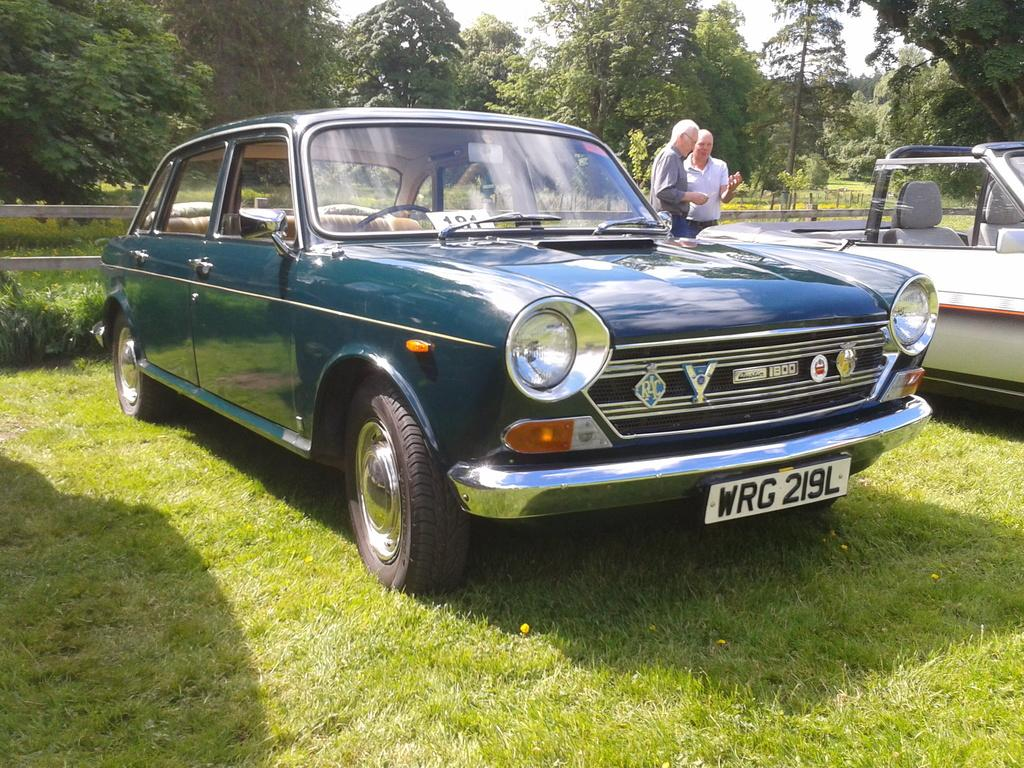What is: What is located on the grass in the image? There are two cars on the grass. What are the men in the background doing? Two men are standing at the cars in the background. What can be seen in the background of the image? There are trees, a fence, and the sky visible in the background. How much sugar is in the cars in the image? There is no sugar present in the cars or the image. What is the cause of death for the trees in the background? There is no indication of any death or problem with the trees in the image; they appear to be healthy. 